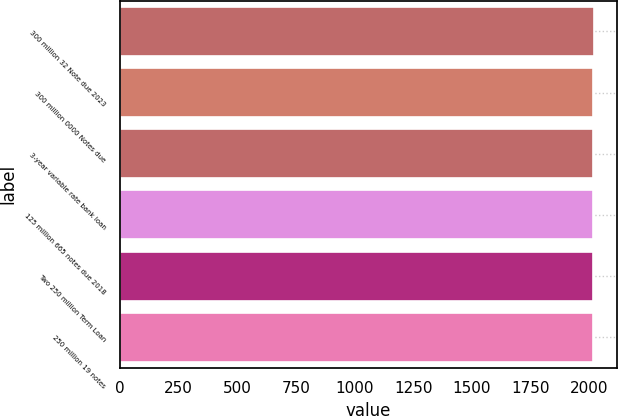Convert chart to OTSL. <chart><loc_0><loc_0><loc_500><loc_500><bar_chart><fcel>300 million 32 Note due 2023<fcel>300 million 0000 Notes due<fcel>3-year variable rate bank loan<fcel>125 million 665 notes due 2018<fcel>Two 250 million Term Loan<fcel>250 million 19 notes<nl><fcel>2018<fcel>2016<fcel>2017<fcel>2016.2<fcel>2016.4<fcel>2016.6<nl></chart> 